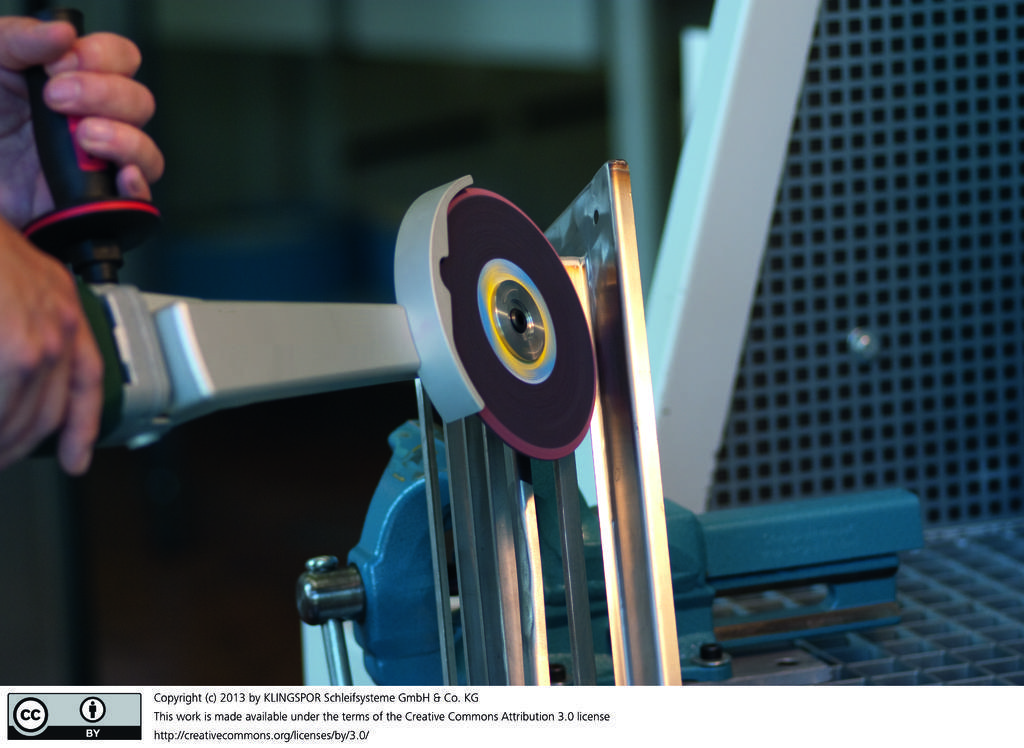In one or two sentences, can you explain what this image depicts? In the image there are two hands of a person holding an object and the background of the object is blue, there is some text and two logos at the bottom of the image. 